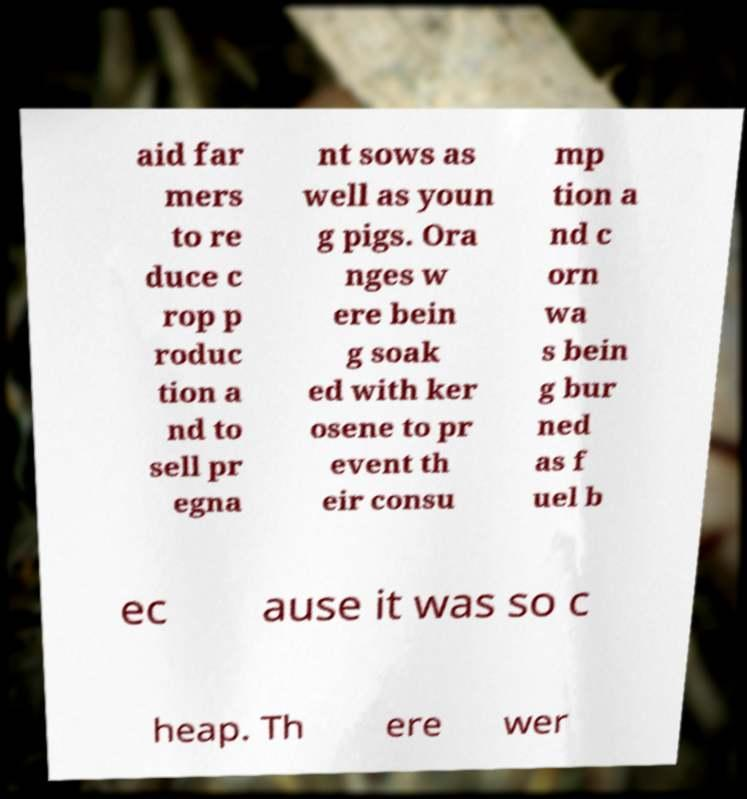Please identify and transcribe the text found in this image. aid far mers to re duce c rop p roduc tion a nd to sell pr egna nt sows as well as youn g pigs. Ora nges w ere bein g soak ed with ker osene to pr event th eir consu mp tion a nd c orn wa s bein g bur ned as f uel b ec ause it was so c heap. Th ere wer 